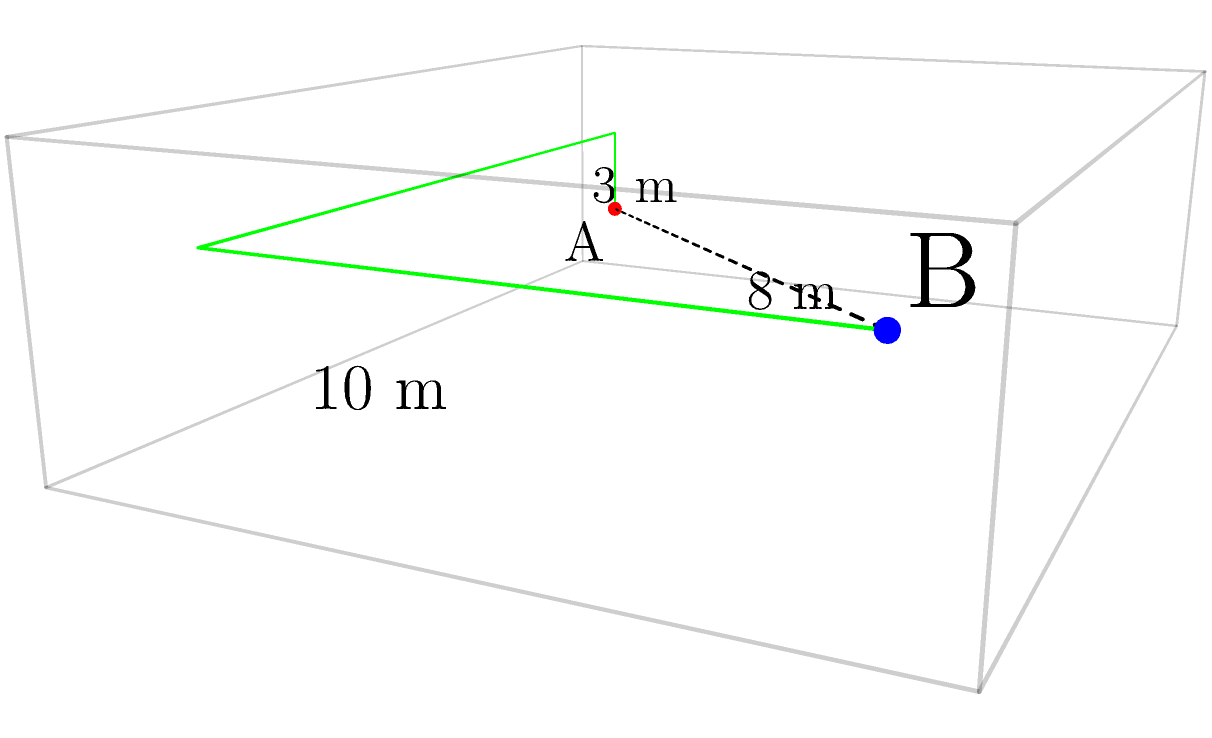In a three-dimensional office space measuring 10m x 8m x 3m, two network nodes A(1,1,1) and B(9,7,2) need to be connected by a cable. The cable must follow the edges of the room (along walls, floor, or ceiling) and cannot pass diagonally through the air. What is the minimum length of cable required to connect these two nodes? To find the most efficient cable routing path, we need to calculate the shortest path along the edges of the room. Let's break this down step-by-step:

1) First, we need to understand that the shortest path will consist of at most three segments: one vertical, one along the length, and one along the width of the room.

2) We can start from point A(1,1,1) and reach point B(9,7,2) in the following order:
   - Move vertically to match B's height: (1,1,1) to (1,1,2)
   - Move along the length of the room: (1,1,2) to (9,1,2)
   - Move along the width of the room: (9,1,2) to (9,7,2)

3) Now, let's calculate the length of each segment:
   - Vertical segment: $|1-2| = 1$ m
   - Length segment: $|1-9| = 8$ m
   - Width segment: $|1-7| = 6$ m

4) The total length of the cable is the sum of these segments:
   $$ \text{Total length} = 1 + 8 + 6 = 15 \text{ m} $$

5) We can verify that this is indeed the shortest path by considering alternatives:
   - Moving along width first, then length: 6 + 8 + 1 = 15 m (same result)
   - Any other path would involve more turns and thus be longer

Therefore, the minimum length of cable required is 15 meters.
Answer: 15 meters 